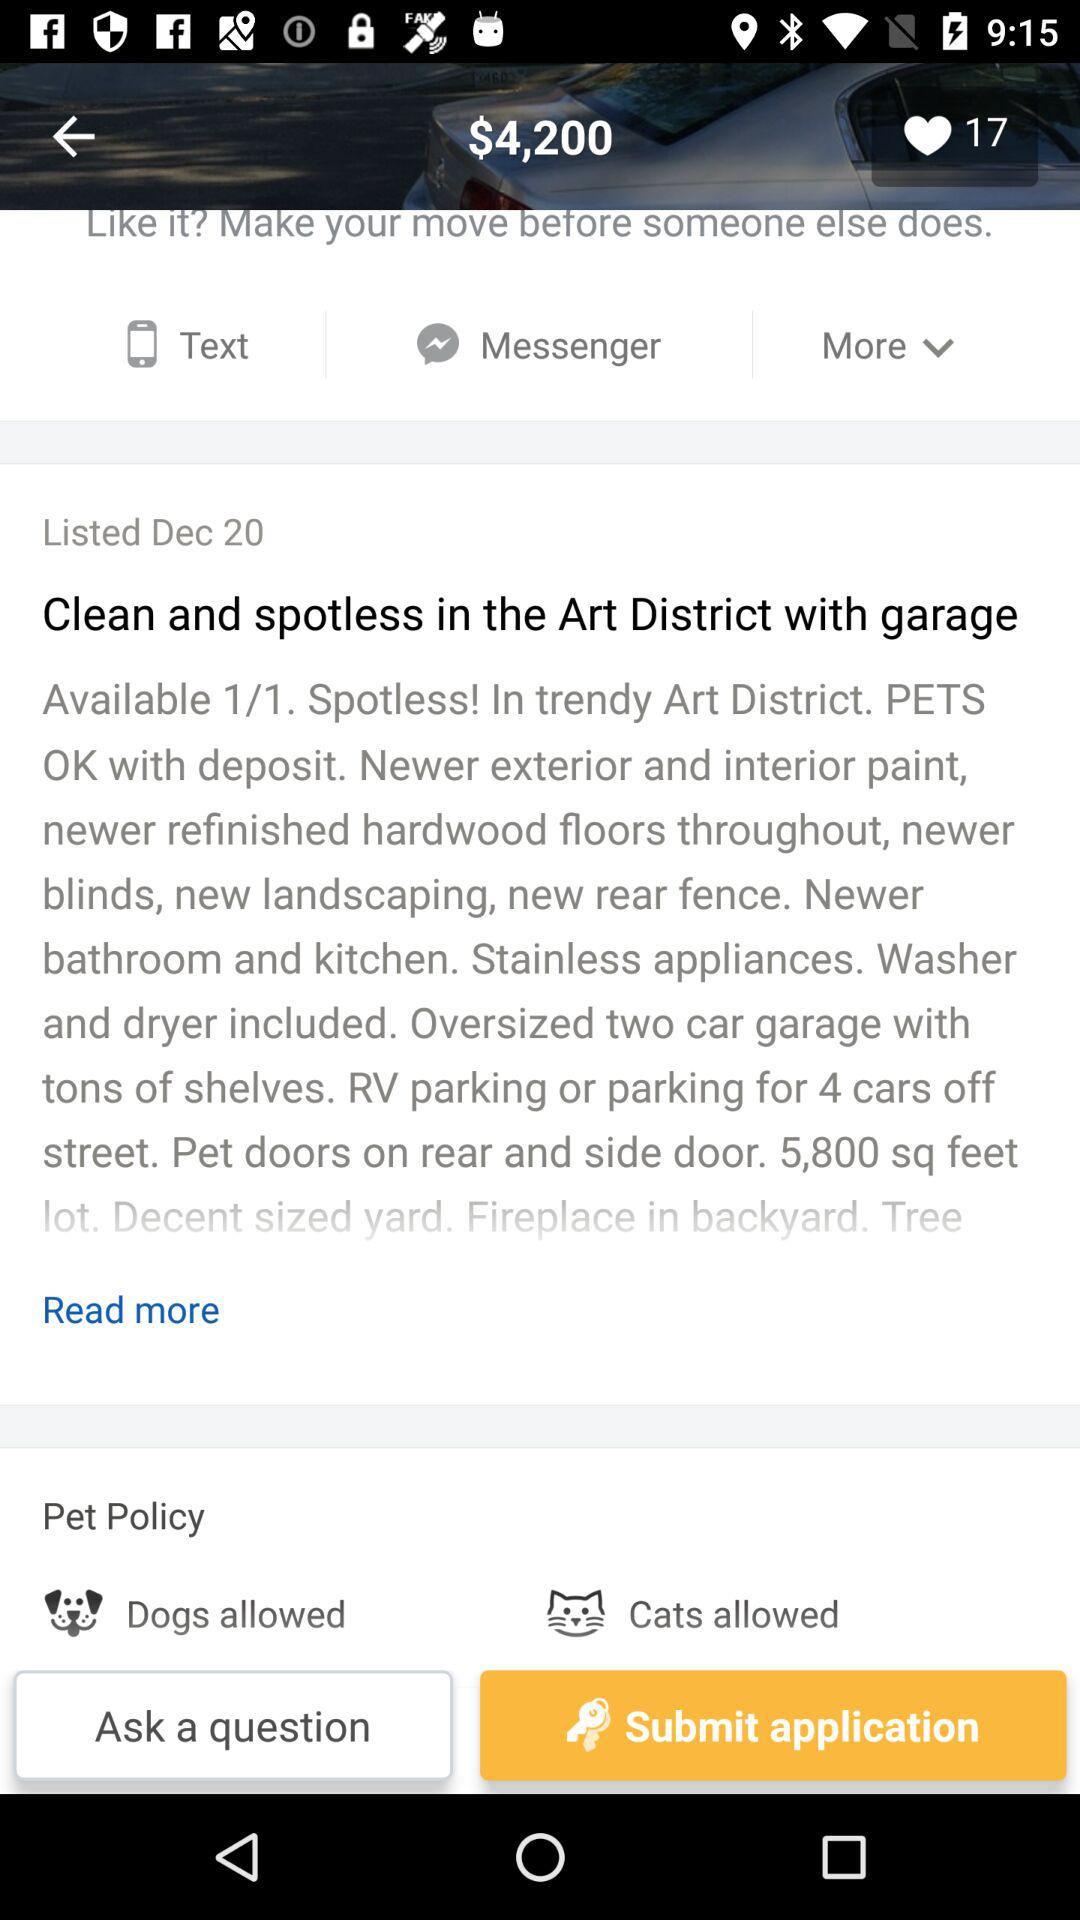What is the headline of the article? The headline of the article is "Clean and spotless in the Art District with garage". 